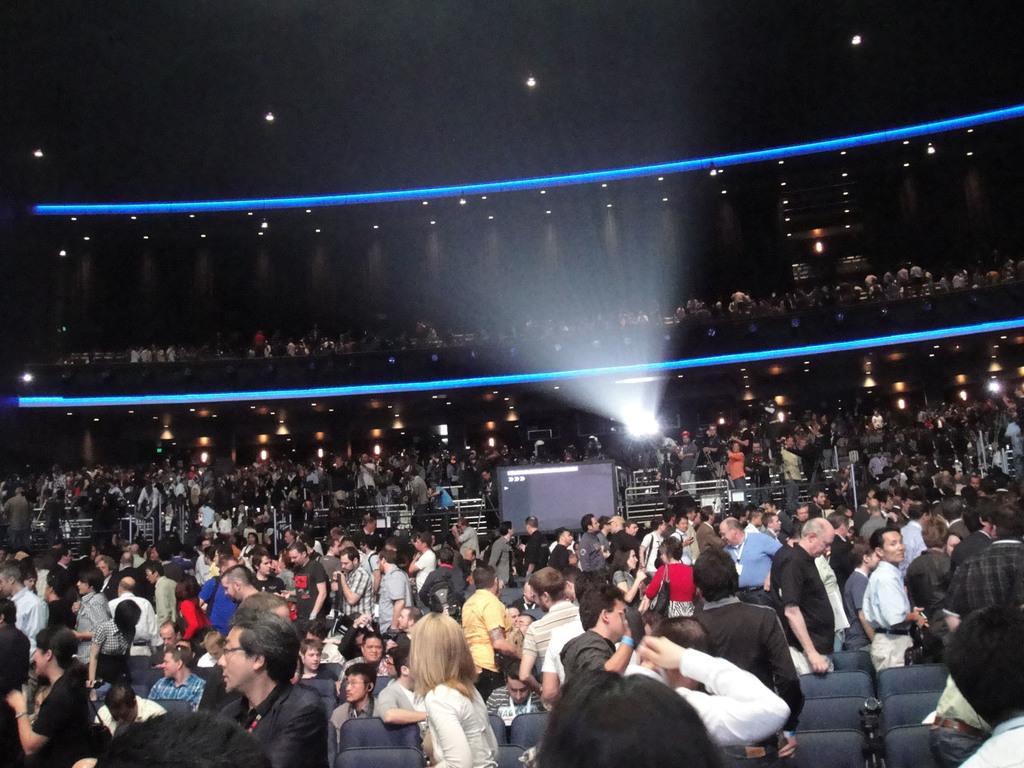Please provide a concise description of this image. In the image we can see there are lot of people standing and others are sitting on the chair. 